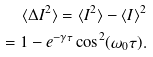<formula> <loc_0><loc_0><loc_500><loc_500>\langle \Delta { I } ^ { 2 } \rangle = \langle { I } ^ { 2 } \rangle - \langle { I } \rangle ^ { 2 } \\ = 1 - e ^ { - \gamma \tau } \cos ^ { 2 } ( \omega _ { 0 } \tau ) .</formula> 